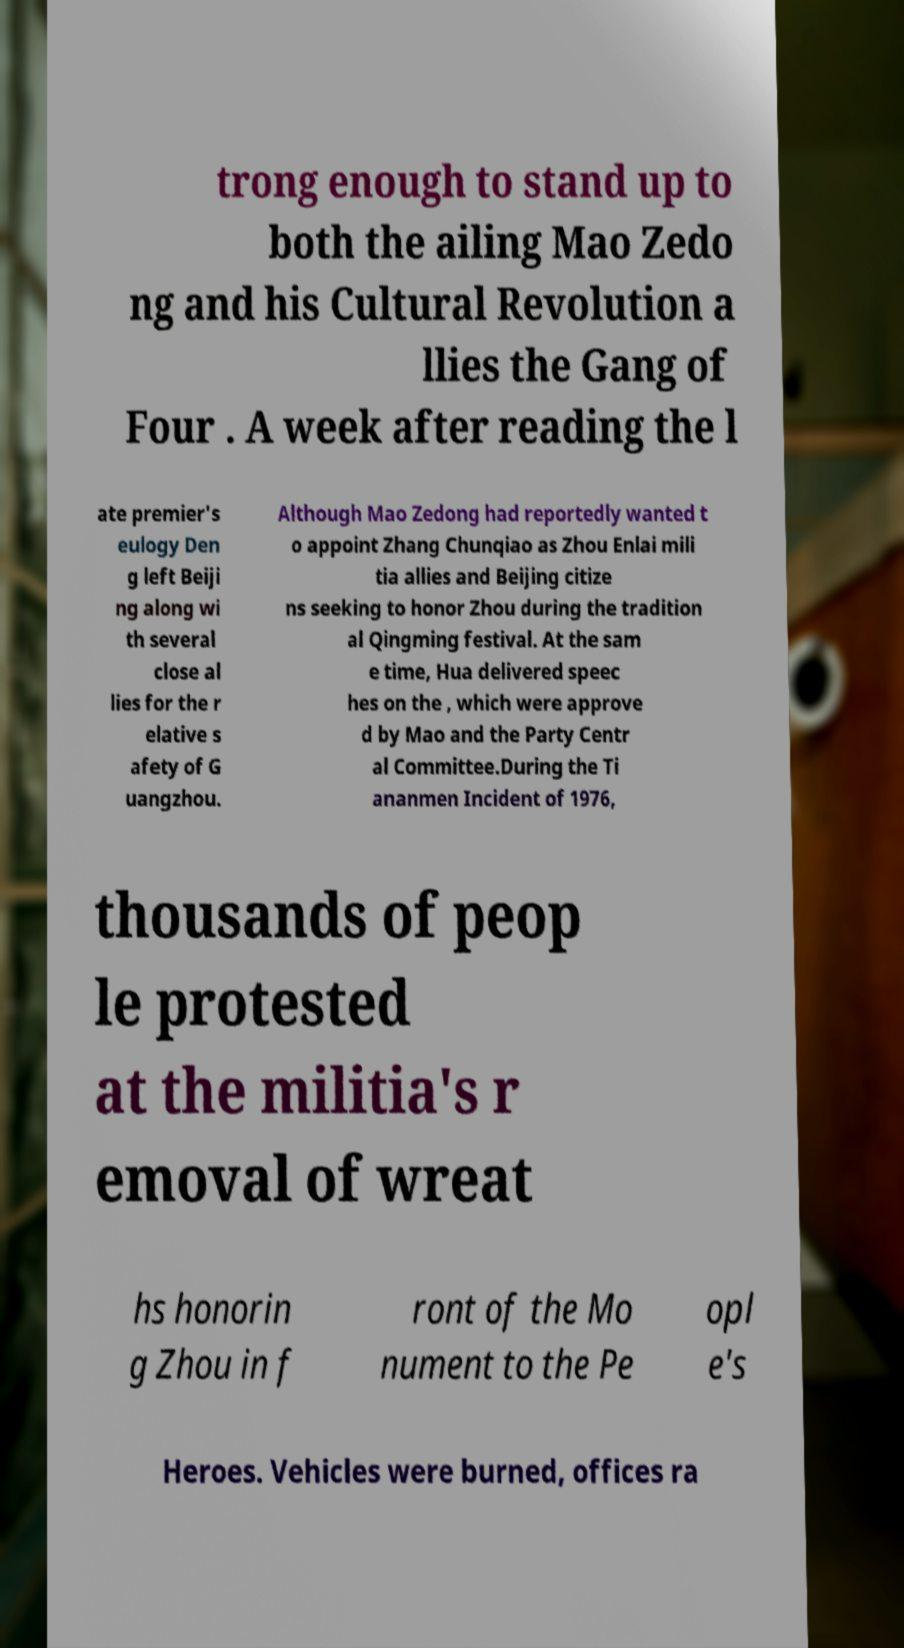Can you read and provide the text displayed in the image?This photo seems to have some interesting text. Can you extract and type it out for me? trong enough to stand up to both the ailing Mao Zedo ng and his Cultural Revolution a llies the Gang of Four . A week after reading the l ate premier's eulogy Den g left Beiji ng along wi th several close al lies for the r elative s afety of G uangzhou. Although Mao Zedong had reportedly wanted t o appoint Zhang Chunqiao as Zhou Enlai mili tia allies and Beijing citize ns seeking to honor Zhou during the tradition al Qingming festival. At the sam e time, Hua delivered speec hes on the , which were approve d by Mao and the Party Centr al Committee.During the Ti ananmen Incident of 1976, thousands of peop le protested at the militia's r emoval of wreat hs honorin g Zhou in f ront of the Mo nument to the Pe opl e's Heroes. Vehicles were burned, offices ra 